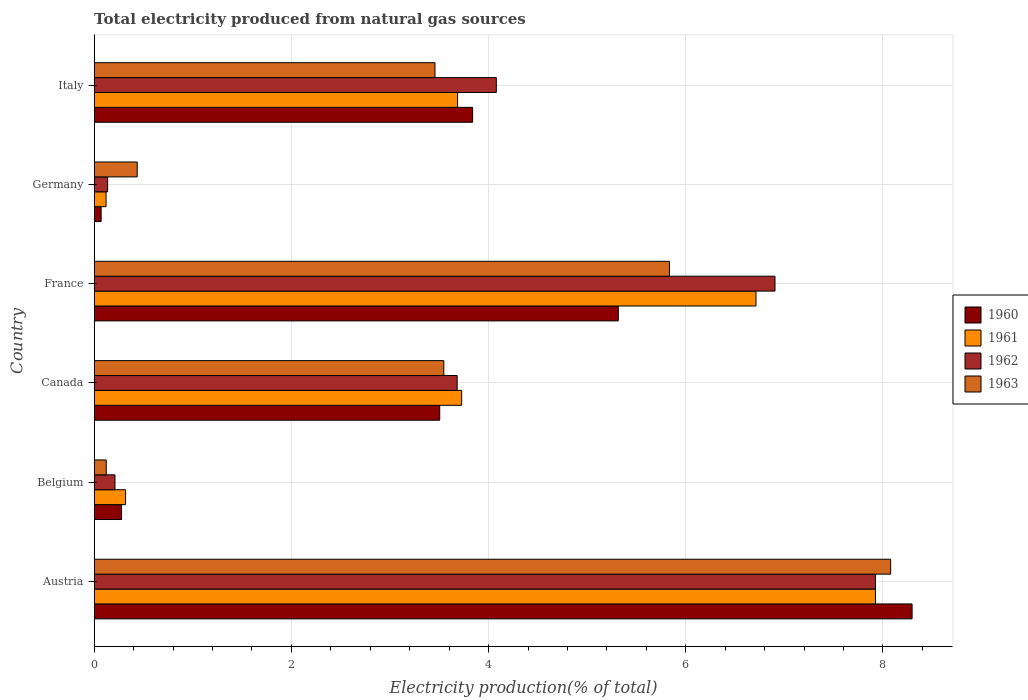Are the number of bars on each tick of the Y-axis equal?
Offer a very short reply. Yes. How many bars are there on the 6th tick from the bottom?
Keep it short and to the point. 4. In how many cases, is the number of bars for a given country not equal to the number of legend labels?
Give a very brief answer. 0. What is the total electricity produced in 1961 in Austria?
Provide a succinct answer. 7.92. Across all countries, what is the maximum total electricity produced in 1963?
Ensure brevity in your answer.  8.08. Across all countries, what is the minimum total electricity produced in 1961?
Provide a short and direct response. 0.12. What is the total total electricity produced in 1960 in the graph?
Give a very brief answer. 21.3. What is the difference between the total electricity produced in 1960 in Austria and that in Belgium?
Offer a very short reply. 8.02. What is the difference between the total electricity produced in 1961 in Austria and the total electricity produced in 1963 in Germany?
Your answer should be compact. 7.49. What is the average total electricity produced in 1961 per country?
Give a very brief answer. 3.75. What is the difference between the total electricity produced in 1963 and total electricity produced in 1961 in Austria?
Make the answer very short. 0.15. In how many countries, is the total electricity produced in 1960 greater than 5.2 %?
Your answer should be very brief. 2. What is the ratio of the total electricity produced in 1963 in Canada to that in Germany?
Keep it short and to the point. 8.13. What is the difference between the highest and the second highest total electricity produced in 1962?
Make the answer very short. 1.02. What is the difference between the highest and the lowest total electricity produced in 1962?
Provide a succinct answer. 7.79. In how many countries, is the total electricity produced in 1962 greater than the average total electricity produced in 1962 taken over all countries?
Provide a succinct answer. 3. Is the sum of the total electricity produced in 1960 in Belgium and Canada greater than the maximum total electricity produced in 1961 across all countries?
Provide a short and direct response. No. What does the 4th bar from the top in France represents?
Ensure brevity in your answer.  1960. What does the 4th bar from the bottom in Canada represents?
Give a very brief answer. 1963. How many bars are there?
Offer a very short reply. 24. Are all the bars in the graph horizontal?
Keep it short and to the point. Yes. How many countries are there in the graph?
Your answer should be compact. 6. What is the difference between two consecutive major ticks on the X-axis?
Your response must be concise. 2. Are the values on the major ticks of X-axis written in scientific E-notation?
Ensure brevity in your answer.  No. Does the graph contain any zero values?
Keep it short and to the point. No. Does the graph contain grids?
Offer a very short reply. Yes. Where does the legend appear in the graph?
Your answer should be very brief. Center right. How are the legend labels stacked?
Keep it short and to the point. Vertical. What is the title of the graph?
Your response must be concise. Total electricity produced from natural gas sources. Does "1966" appear as one of the legend labels in the graph?
Ensure brevity in your answer.  No. What is the label or title of the X-axis?
Give a very brief answer. Electricity production(% of total). What is the label or title of the Y-axis?
Provide a short and direct response. Country. What is the Electricity production(% of total) in 1960 in Austria?
Provide a succinct answer. 8.3. What is the Electricity production(% of total) of 1961 in Austria?
Your answer should be very brief. 7.92. What is the Electricity production(% of total) of 1962 in Austria?
Your response must be concise. 7.92. What is the Electricity production(% of total) of 1963 in Austria?
Keep it short and to the point. 8.08. What is the Electricity production(% of total) of 1960 in Belgium?
Keep it short and to the point. 0.28. What is the Electricity production(% of total) in 1961 in Belgium?
Offer a very short reply. 0.32. What is the Electricity production(% of total) of 1962 in Belgium?
Your answer should be very brief. 0.21. What is the Electricity production(% of total) of 1963 in Belgium?
Provide a short and direct response. 0.12. What is the Electricity production(% of total) in 1960 in Canada?
Provide a short and direct response. 3.5. What is the Electricity production(% of total) in 1961 in Canada?
Your answer should be very brief. 3.73. What is the Electricity production(% of total) of 1962 in Canada?
Your response must be concise. 3.68. What is the Electricity production(% of total) of 1963 in Canada?
Make the answer very short. 3.55. What is the Electricity production(% of total) in 1960 in France?
Make the answer very short. 5.32. What is the Electricity production(% of total) in 1961 in France?
Your answer should be very brief. 6.71. What is the Electricity production(% of total) in 1962 in France?
Offer a very short reply. 6.91. What is the Electricity production(% of total) of 1963 in France?
Provide a short and direct response. 5.83. What is the Electricity production(% of total) of 1960 in Germany?
Offer a terse response. 0.07. What is the Electricity production(% of total) of 1961 in Germany?
Make the answer very short. 0.12. What is the Electricity production(% of total) in 1962 in Germany?
Give a very brief answer. 0.14. What is the Electricity production(% of total) of 1963 in Germany?
Provide a short and direct response. 0.44. What is the Electricity production(% of total) of 1960 in Italy?
Keep it short and to the point. 3.84. What is the Electricity production(% of total) in 1961 in Italy?
Give a very brief answer. 3.69. What is the Electricity production(% of total) of 1962 in Italy?
Keep it short and to the point. 4.08. What is the Electricity production(% of total) in 1963 in Italy?
Provide a succinct answer. 3.46. Across all countries, what is the maximum Electricity production(% of total) in 1960?
Your answer should be very brief. 8.3. Across all countries, what is the maximum Electricity production(% of total) of 1961?
Keep it short and to the point. 7.92. Across all countries, what is the maximum Electricity production(% of total) of 1962?
Give a very brief answer. 7.92. Across all countries, what is the maximum Electricity production(% of total) of 1963?
Make the answer very short. 8.08. Across all countries, what is the minimum Electricity production(% of total) of 1960?
Your answer should be compact. 0.07. Across all countries, what is the minimum Electricity production(% of total) of 1961?
Your answer should be compact. 0.12. Across all countries, what is the minimum Electricity production(% of total) of 1962?
Keep it short and to the point. 0.14. Across all countries, what is the minimum Electricity production(% of total) in 1963?
Give a very brief answer. 0.12. What is the total Electricity production(% of total) of 1960 in the graph?
Give a very brief answer. 21.3. What is the total Electricity production(% of total) in 1961 in the graph?
Provide a short and direct response. 22.49. What is the total Electricity production(% of total) in 1962 in the graph?
Offer a terse response. 22.94. What is the total Electricity production(% of total) of 1963 in the graph?
Provide a succinct answer. 21.47. What is the difference between the Electricity production(% of total) in 1960 in Austria and that in Belgium?
Give a very brief answer. 8.02. What is the difference between the Electricity production(% of total) in 1961 in Austria and that in Belgium?
Give a very brief answer. 7.61. What is the difference between the Electricity production(% of total) of 1962 in Austria and that in Belgium?
Give a very brief answer. 7.71. What is the difference between the Electricity production(% of total) in 1963 in Austria and that in Belgium?
Provide a short and direct response. 7.96. What is the difference between the Electricity production(% of total) in 1960 in Austria and that in Canada?
Provide a short and direct response. 4.79. What is the difference between the Electricity production(% of total) in 1961 in Austria and that in Canada?
Provide a succinct answer. 4.2. What is the difference between the Electricity production(% of total) of 1962 in Austria and that in Canada?
Provide a succinct answer. 4.24. What is the difference between the Electricity production(% of total) of 1963 in Austria and that in Canada?
Your answer should be very brief. 4.53. What is the difference between the Electricity production(% of total) of 1960 in Austria and that in France?
Give a very brief answer. 2.98. What is the difference between the Electricity production(% of total) of 1961 in Austria and that in France?
Your response must be concise. 1.21. What is the difference between the Electricity production(% of total) of 1962 in Austria and that in France?
Give a very brief answer. 1.02. What is the difference between the Electricity production(% of total) of 1963 in Austria and that in France?
Ensure brevity in your answer.  2.24. What is the difference between the Electricity production(% of total) in 1960 in Austria and that in Germany?
Your answer should be compact. 8.23. What is the difference between the Electricity production(% of total) in 1961 in Austria and that in Germany?
Provide a succinct answer. 7.8. What is the difference between the Electricity production(% of total) of 1962 in Austria and that in Germany?
Keep it short and to the point. 7.79. What is the difference between the Electricity production(% of total) of 1963 in Austria and that in Germany?
Your response must be concise. 7.64. What is the difference between the Electricity production(% of total) of 1960 in Austria and that in Italy?
Provide a succinct answer. 4.46. What is the difference between the Electricity production(% of total) of 1961 in Austria and that in Italy?
Your answer should be compact. 4.24. What is the difference between the Electricity production(% of total) of 1962 in Austria and that in Italy?
Provide a short and direct response. 3.85. What is the difference between the Electricity production(% of total) in 1963 in Austria and that in Italy?
Make the answer very short. 4.62. What is the difference between the Electricity production(% of total) in 1960 in Belgium and that in Canada?
Give a very brief answer. -3.23. What is the difference between the Electricity production(% of total) in 1961 in Belgium and that in Canada?
Offer a terse response. -3.41. What is the difference between the Electricity production(% of total) of 1962 in Belgium and that in Canada?
Your answer should be very brief. -3.47. What is the difference between the Electricity production(% of total) of 1963 in Belgium and that in Canada?
Provide a succinct answer. -3.42. What is the difference between the Electricity production(% of total) of 1960 in Belgium and that in France?
Your response must be concise. -5.04. What is the difference between the Electricity production(% of total) in 1961 in Belgium and that in France?
Your response must be concise. -6.39. What is the difference between the Electricity production(% of total) in 1962 in Belgium and that in France?
Your answer should be compact. -6.69. What is the difference between the Electricity production(% of total) in 1963 in Belgium and that in France?
Make the answer very short. -5.71. What is the difference between the Electricity production(% of total) in 1960 in Belgium and that in Germany?
Ensure brevity in your answer.  0.21. What is the difference between the Electricity production(% of total) of 1961 in Belgium and that in Germany?
Your answer should be compact. 0.2. What is the difference between the Electricity production(% of total) in 1962 in Belgium and that in Germany?
Ensure brevity in your answer.  0.07. What is the difference between the Electricity production(% of total) of 1963 in Belgium and that in Germany?
Offer a terse response. -0.31. What is the difference between the Electricity production(% of total) of 1960 in Belgium and that in Italy?
Ensure brevity in your answer.  -3.56. What is the difference between the Electricity production(% of total) in 1961 in Belgium and that in Italy?
Offer a very short reply. -3.37. What is the difference between the Electricity production(% of total) of 1962 in Belgium and that in Italy?
Provide a short and direct response. -3.87. What is the difference between the Electricity production(% of total) of 1963 in Belgium and that in Italy?
Offer a terse response. -3.33. What is the difference between the Electricity production(% of total) in 1960 in Canada and that in France?
Give a very brief answer. -1.81. What is the difference between the Electricity production(% of total) in 1961 in Canada and that in France?
Offer a terse response. -2.99. What is the difference between the Electricity production(% of total) in 1962 in Canada and that in France?
Make the answer very short. -3.22. What is the difference between the Electricity production(% of total) in 1963 in Canada and that in France?
Your answer should be very brief. -2.29. What is the difference between the Electricity production(% of total) in 1960 in Canada and that in Germany?
Your answer should be very brief. 3.43. What is the difference between the Electricity production(% of total) in 1961 in Canada and that in Germany?
Your response must be concise. 3.61. What is the difference between the Electricity production(% of total) of 1962 in Canada and that in Germany?
Make the answer very short. 3.55. What is the difference between the Electricity production(% of total) in 1963 in Canada and that in Germany?
Ensure brevity in your answer.  3.11. What is the difference between the Electricity production(% of total) in 1960 in Canada and that in Italy?
Provide a short and direct response. -0.33. What is the difference between the Electricity production(% of total) in 1961 in Canada and that in Italy?
Provide a short and direct response. 0.04. What is the difference between the Electricity production(% of total) of 1962 in Canada and that in Italy?
Your response must be concise. -0.4. What is the difference between the Electricity production(% of total) in 1963 in Canada and that in Italy?
Make the answer very short. 0.09. What is the difference between the Electricity production(% of total) of 1960 in France and that in Germany?
Your answer should be very brief. 5.25. What is the difference between the Electricity production(% of total) in 1961 in France and that in Germany?
Your answer should be very brief. 6.59. What is the difference between the Electricity production(% of total) in 1962 in France and that in Germany?
Offer a very short reply. 6.77. What is the difference between the Electricity production(% of total) in 1963 in France and that in Germany?
Make the answer very short. 5.4. What is the difference between the Electricity production(% of total) in 1960 in France and that in Italy?
Offer a terse response. 1.48. What is the difference between the Electricity production(% of total) in 1961 in France and that in Italy?
Offer a very short reply. 3.03. What is the difference between the Electricity production(% of total) in 1962 in France and that in Italy?
Your answer should be very brief. 2.83. What is the difference between the Electricity production(% of total) of 1963 in France and that in Italy?
Your response must be concise. 2.38. What is the difference between the Electricity production(% of total) of 1960 in Germany and that in Italy?
Provide a succinct answer. -3.77. What is the difference between the Electricity production(% of total) in 1961 in Germany and that in Italy?
Give a very brief answer. -3.57. What is the difference between the Electricity production(% of total) in 1962 in Germany and that in Italy?
Offer a very short reply. -3.94. What is the difference between the Electricity production(% of total) in 1963 in Germany and that in Italy?
Offer a terse response. -3.02. What is the difference between the Electricity production(% of total) in 1960 in Austria and the Electricity production(% of total) in 1961 in Belgium?
Provide a short and direct response. 7.98. What is the difference between the Electricity production(% of total) in 1960 in Austria and the Electricity production(% of total) in 1962 in Belgium?
Your answer should be compact. 8.08. What is the difference between the Electricity production(% of total) in 1960 in Austria and the Electricity production(% of total) in 1963 in Belgium?
Provide a succinct answer. 8.17. What is the difference between the Electricity production(% of total) of 1961 in Austria and the Electricity production(% of total) of 1962 in Belgium?
Your answer should be very brief. 7.71. What is the difference between the Electricity production(% of total) of 1961 in Austria and the Electricity production(% of total) of 1963 in Belgium?
Offer a terse response. 7.8. What is the difference between the Electricity production(% of total) in 1962 in Austria and the Electricity production(% of total) in 1963 in Belgium?
Offer a very short reply. 7.8. What is the difference between the Electricity production(% of total) in 1960 in Austria and the Electricity production(% of total) in 1961 in Canada?
Ensure brevity in your answer.  4.57. What is the difference between the Electricity production(% of total) of 1960 in Austria and the Electricity production(% of total) of 1962 in Canada?
Your answer should be very brief. 4.61. What is the difference between the Electricity production(% of total) of 1960 in Austria and the Electricity production(% of total) of 1963 in Canada?
Your response must be concise. 4.75. What is the difference between the Electricity production(% of total) of 1961 in Austria and the Electricity production(% of total) of 1962 in Canada?
Your answer should be very brief. 4.24. What is the difference between the Electricity production(% of total) in 1961 in Austria and the Electricity production(% of total) in 1963 in Canada?
Give a very brief answer. 4.38. What is the difference between the Electricity production(% of total) in 1962 in Austria and the Electricity production(% of total) in 1963 in Canada?
Ensure brevity in your answer.  4.38. What is the difference between the Electricity production(% of total) in 1960 in Austria and the Electricity production(% of total) in 1961 in France?
Provide a succinct answer. 1.58. What is the difference between the Electricity production(% of total) of 1960 in Austria and the Electricity production(% of total) of 1962 in France?
Make the answer very short. 1.39. What is the difference between the Electricity production(% of total) in 1960 in Austria and the Electricity production(% of total) in 1963 in France?
Provide a succinct answer. 2.46. What is the difference between the Electricity production(% of total) in 1961 in Austria and the Electricity production(% of total) in 1963 in France?
Your answer should be compact. 2.09. What is the difference between the Electricity production(% of total) of 1962 in Austria and the Electricity production(% of total) of 1963 in France?
Ensure brevity in your answer.  2.09. What is the difference between the Electricity production(% of total) in 1960 in Austria and the Electricity production(% of total) in 1961 in Germany?
Provide a short and direct response. 8.18. What is the difference between the Electricity production(% of total) of 1960 in Austria and the Electricity production(% of total) of 1962 in Germany?
Offer a very short reply. 8.16. What is the difference between the Electricity production(% of total) in 1960 in Austria and the Electricity production(% of total) in 1963 in Germany?
Offer a very short reply. 7.86. What is the difference between the Electricity production(% of total) in 1961 in Austria and the Electricity production(% of total) in 1962 in Germany?
Give a very brief answer. 7.79. What is the difference between the Electricity production(% of total) in 1961 in Austria and the Electricity production(% of total) in 1963 in Germany?
Your response must be concise. 7.49. What is the difference between the Electricity production(% of total) of 1962 in Austria and the Electricity production(% of total) of 1963 in Germany?
Offer a terse response. 7.49. What is the difference between the Electricity production(% of total) in 1960 in Austria and the Electricity production(% of total) in 1961 in Italy?
Ensure brevity in your answer.  4.61. What is the difference between the Electricity production(% of total) of 1960 in Austria and the Electricity production(% of total) of 1962 in Italy?
Offer a very short reply. 4.22. What is the difference between the Electricity production(% of total) of 1960 in Austria and the Electricity production(% of total) of 1963 in Italy?
Your answer should be compact. 4.84. What is the difference between the Electricity production(% of total) of 1961 in Austria and the Electricity production(% of total) of 1962 in Italy?
Make the answer very short. 3.85. What is the difference between the Electricity production(% of total) in 1961 in Austria and the Electricity production(% of total) in 1963 in Italy?
Provide a short and direct response. 4.47. What is the difference between the Electricity production(% of total) of 1962 in Austria and the Electricity production(% of total) of 1963 in Italy?
Make the answer very short. 4.47. What is the difference between the Electricity production(% of total) of 1960 in Belgium and the Electricity production(% of total) of 1961 in Canada?
Provide a succinct answer. -3.45. What is the difference between the Electricity production(% of total) in 1960 in Belgium and the Electricity production(% of total) in 1962 in Canada?
Your response must be concise. -3.4. What is the difference between the Electricity production(% of total) of 1960 in Belgium and the Electricity production(% of total) of 1963 in Canada?
Provide a succinct answer. -3.27. What is the difference between the Electricity production(% of total) of 1961 in Belgium and the Electricity production(% of total) of 1962 in Canada?
Provide a short and direct response. -3.36. What is the difference between the Electricity production(% of total) of 1961 in Belgium and the Electricity production(% of total) of 1963 in Canada?
Give a very brief answer. -3.23. What is the difference between the Electricity production(% of total) in 1962 in Belgium and the Electricity production(% of total) in 1963 in Canada?
Keep it short and to the point. -3.34. What is the difference between the Electricity production(% of total) of 1960 in Belgium and the Electricity production(% of total) of 1961 in France?
Ensure brevity in your answer.  -6.43. What is the difference between the Electricity production(% of total) in 1960 in Belgium and the Electricity production(% of total) in 1962 in France?
Provide a succinct answer. -6.63. What is the difference between the Electricity production(% of total) in 1960 in Belgium and the Electricity production(% of total) in 1963 in France?
Offer a terse response. -5.56. What is the difference between the Electricity production(% of total) of 1961 in Belgium and the Electricity production(% of total) of 1962 in France?
Your answer should be compact. -6.59. What is the difference between the Electricity production(% of total) in 1961 in Belgium and the Electricity production(% of total) in 1963 in France?
Make the answer very short. -5.52. What is the difference between the Electricity production(% of total) in 1962 in Belgium and the Electricity production(% of total) in 1963 in France?
Provide a short and direct response. -5.62. What is the difference between the Electricity production(% of total) in 1960 in Belgium and the Electricity production(% of total) in 1961 in Germany?
Ensure brevity in your answer.  0.16. What is the difference between the Electricity production(% of total) of 1960 in Belgium and the Electricity production(% of total) of 1962 in Germany?
Ensure brevity in your answer.  0.14. What is the difference between the Electricity production(% of total) in 1960 in Belgium and the Electricity production(% of total) in 1963 in Germany?
Offer a very short reply. -0.16. What is the difference between the Electricity production(% of total) in 1961 in Belgium and the Electricity production(% of total) in 1962 in Germany?
Make the answer very short. 0.18. What is the difference between the Electricity production(% of total) of 1961 in Belgium and the Electricity production(% of total) of 1963 in Germany?
Your response must be concise. -0.12. What is the difference between the Electricity production(% of total) of 1962 in Belgium and the Electricity production(% of total) of 1963 in Germany?
Your answer should be very brief. -0.23. What is the difference between the Electricity production(% of total) in 1960 in Belgium and the Electricity production(% of total) in 1961 in Italy?
Keep it short and to the point. -3.41. What is the difference between the Electricity production(% of total) of 1960 in Belgium and the Electricity production(% of total) of 1962 in Italy?
Offer a terse response. -3.8. What is the difference between the Electricity production(% of total) in 1960 in Belgium and the Electricity production(% of total) in 1963 in Italy?
Provide a succinct answer. -3.18. What is the difference between the Electricity production(% of total) in 1961 in Belgium and the Electricity production(% of total) in 1962 in Italy?
Ensure brevity in your answer.  -3.76. What is the difference between the Electricity production(% of total) of 1961 in Belgium and the Electricity production(% of total) of 1963 in Italy?
Give a very brief answer. -3.14. What is the difference between the Electricity production(% of total) of 1962 in Belgium and the Electricity production(% of total) of 1963 in Italy?
Provide a short and direct response. -3.25. What is the difference between the Electricity production(% of total) of 1960 in Canada and the Electricity production(% of total) of 1961 in France?
Give a very brief answer. -3.21. What is the difference between the Electricity production(% of total) in 1960 in Canada and the Electricity production(% of total) in 1962 in France?
Give a very brief answer. -3.4. What is the difference between the Electricity production(% of total) in 1960 in Canada and the Electricity production(% of total) in 1963 in France?
Provide a short and direct response. -2.33. What is the difference between the Electricity production(% of total) of 1961 in Canada and the Electricity production(% of total) of 1962 in France?
Your answer should be compact. -3.18. What is the difference between the Electricity production(% of total) of 1961 in Canada and the Electricity production(% of total) of 1963 in France?
Your answer should be compact. -2.11. What is the difference between the Electricity production(% of total) in 1962 in Canada and the Electricity production(% of total) in 1963 in France?
Offer a terse response. -2.15. What is the difference between the Electricity production(% of total) of 1960 in Canada and the Electricity production(% of total) of 1961 in Germany?
Ensure brevity in your answer.  3.38. What is the difference between the Electricity production(% of total) in 1960 in Canada and the Electricity production(% of total) in 1962 in Germany?
Ensure brevity in your answer.  3.37. What is the difference between the Electricity production(% of total) of 1960 in Canada and the Electricity production(% of total) of 1963 in Germany?
Your answer should be very brief. 3.07. What is the difference between the Electricity production(% of total) in 1961 in Canada and the Electricity production(% of total) in 1962 in Germany?
Make the answer very short. 3.59. What is the difference between the Electricity production(% of total) of 1961 in Canada and the Electricity production(% of total) of 1963 in Germany?
Offer a terse response. 3.29. What is the difference between the Electricity production(% of total) in 1962 in Canada and the Electricity production(% of total) in 1963 in Germany?
Keep it short and to the point. 3.25. What is the difference between the Electricity production(% of total) in 1960 in Canada and the Electricity production(% of total) in 1961 in Italy?
Give a very brief answer. -0.18. What is the difference between the Electricity production(% of total) of 1960 in Canada and the Electricity production(% of total) of 1962 in Italy?
Give a very brief answer. -0.57. What is the difference between the Electricity production(% of total) in 1960 in Canada and the Electricity production(% of total) in 1963 in Italy?
Make the answer very short. 0.05. What is the difference between the Electricity production(% of total) in 1961 in Canada and the Electricity production(% of total) in 1962 in Italy?
Provide a succinct answer. -0.35. What is the difference between the Electricity production(% of total) of 1961 in Canada and the Electricity production(% of total) of 1963 in Italy?
Offer a very short reply. 0.27. What is the difference between the Electricity production(% of total) of 1962 in Canada and the Electricity production(% of total) of 1963 in Italy?
Keep it short and to the point. 0.23. What is the difference between the Electricity production(% of total) in 1960 in France and the Electricity production(% of total) in 1961 in Germany?
Give a very brief answer. 5.2. What is the difference between the Electricity production(% of total) in 1960 in France and the Electricity production(% of total) in 1962 in Germany?
Provide a succinct answer. 5.18. What is the difference between the Electricity production(% of total) of 1960 in France and the Electricity production(% of total) of 1963 in Germany?
Provide a short and direct response. 4.88. What is the difference between the Electricity production(% of total) in 1961 in France and the Electricity production(% of total) in 1962 in Germany?
Provide a succinct answer. 6.58. What is the difference between the Electricity production(% of total) of 1961 in France and the Electricity production(% of total) of 1963 in Germany?
Give a very brief answer. 6.28. What is the difference between the Electricity production(% of total) of 1962 in France and the Electricity production(% of total) of 1963 in Germany?
Give a very brief answer. 6.47. What is the difference between the Electricity production(% of total) of 1960 in France and the Electricity production(% of total) of 1961 in Italy?
Provide a succinct answer. 1.63. What is the difference between the Electricity production(% of total) in 1960 in France and the Electricity production(% of total) in 1962 in Italy?
Your answer should be very brief. 1.24. What is the difference between the Electricity production(% of total) of 1960 in France and the Electricity production(% of total) of 1963 in Italy?
Provide a short and direct response. 1.86. What is the difference between the Electricity production(% of total) of 1961 in France and the Electricity production(% of total) of 1962 in Italy?
Provide a short and direct response. 2.63. What is the difference between the Electricity production(% of total) of 1961 in France and the Electricity production(% of total) of 1963 in Italy?
Provide a short and direct response. 3.26. What is the difference between the Electricity production(% of total) of 1962 in France and the Electricity production(% of total) of 1963 in Italy?
Your response must be concise. 3.45. What is the difference between the Electricity production(% of total) in 1960 in Germany and the Electricity production(% of total) in 1961 in Italy?
Offer a terse response. -3.62. What is the difference between the Electricity production(% of total) in 1960 in Germany and the Electricity production(% of total) in 1962 in Italy?
Offer a terse response. -4.01. What is the difference between the Electricity production(% of total) in 1960 in Germany and the Electricity production(% of total) in 1963 in Italy?
Make the answer very short. -3.39. What is the difference between the Electricity production(% of total) in 1961 in Germany and the Electricity production(% of total) in 1962 in Italy?
Ensure brevity in your answer.  -3.96. What is the difference between the Electricity production(% of total) of 1961 in Germany and the Electricity production(% of total) of 1963 in Italy?
Your answer should be very brief. -3.34. What is the difference between the Electricity production(% of total) of 1962 in Germany and the Electricity production(% of total) of 1963 in Italy?
Ensure brevity in your answer.  -3.32. What is the average Electricity production(% of total) of 1960 per country?
Offer a very short reply. 3.55. What is the average Electricity production(% of total) in 1961 per country?
Your response must be concise. 3.75. What is the average Electricity production(% of total) of 1962 per country?
Your response must be concise. 3.82. What is the average Electricity production(% of total) in 1963 per country?
Make the answer very short. 3.58. What is the difference between the Electricity production(% of total) in 1960 and Electricity production(% of total) in 1961 in Austria?
Give a very brief answer. 0.37. What is the difference between the Electricity production(% of total) of 1960 and Electricity production(% of total) of 1962 in Austria?
Provide a short and direct response. 0.37. What is the difference between the Electricity production(% of total) of 1960 and Electricity production(% of total) of 1963 in Austria?
Offer a terse response. 0.22. What is the difference between the Electricity production(% of total) in 1961 and Electricity production(% of total) in 1963 in Austria?
Offer a terse response. -0.15. What is the difference between the Electricity production(% of total) in 1962 and Electricity production(% of total) in 1963 in Austria?
Your answer should be very brief. -0.15. What is the difference between the Electricity production(% of total) in 1960 and Electricity production(% of total) in 1961 in Belgium?
Make the answer very short. -0.04. What is the difference between the Electricity production(% of total) of 1960 and Electricity production(% of total) of 1962 in Belgium?
Your answer should be very brief. 0.07. What is the difference between the Electricity production(% of total) of 1960 and Electricity production(% of total) of 1963 in Belgium?
Keep it short and to the point. 0.15. What is the difference between the Electricity production(% of total) of 1961 and Electricity production(% of total) of 1962 in Belgium?
Provide a succinct answer. 0.11. What is the difference between the Electricity production(% of total) in 1961 and Electricity production(% of total) in 1963 in Belgium?
Make the answer very short. 0.2. What is the difference between the Electricity production(% of total) of 1962 and Electricity production(% of total) of 1963 in Belgium?
Your answer should be compact. 0.09. What is the difference between the Electricity production(% of total) of 1960 and Electricity production(% of total) of 1961 in Canada?
Keep it short and to the point. -0.22. What is the difference between the Electricity production(% of total) of 1960 and Electricity production(% of total) of 1962 in Canada?
Keep it short and to the point. -0.18. What is the difference between the Electricity production(% of total) of 1960 and Electricity production(% of total) of 1963 in Canada?
Make the answer very short. -0.04. What is the difference between the Electricity production(% of total) in 1961 and Electricity production(% of total) in 1962 in Canada?
Ensure brevity in your answer.  0.05. What is the difference between the Electricity production(% of total) of 1961 and Electricity production(% of total) of 1963 in Canada?
Give a very brief answer. 0.18. What is the difference between the Electricity production(% of total) in 1962 and Electricity production(% of total) in 1963 in Canada?
Keep it short and to the point. 0.14. What is the difference between the Electricity production(% of total) of 1960 and Electricity production(% of total) of 1961 in France?
Provide a succinct answer. -1.4. What is the difference between the Electricity production(% of total) of 1960 and Electricity production(% of total) of 1962 in France?
Make the answer very short. -1.59. What is the difference between the Electricity production(% of total) in 1960 and Electricity production(% of total) in 1963 in France?
Your response must be concise. -0.52. What is the difference between the Electricity production(% of total) in 1961 and Electricity production(% of total) in 1962 in France?
Make the answer very short. -0.19. What is the difference between the Electricity production(% of total) in 1961 and Electricity production(% of total) in 1963 in France?
Give a very brief answer. 0.88. What is the difference between the Electricity production(% of total) of 1962 and Electricity production(% of total) of 1963 in France?
Provide a succinct answer. 1.07. What is the difference between the Electricity production(% of total) in 1960 and Electricity production(% of total) in 1962 in Germany?
Your answer should be very brief. -0.07. What is the difference between the Electricity production(% of total) of 1960 and Electricity production(% of total) of 1963 in Germany?
Make the answer very short. -0.37. What is the difference between the Electricity production(% of total) of 1961 and Electricity production(% of total) of 1962 in Germany?
Make the answer very short. -0.02. What is the difference between the Electricity production(% of total) in 1961 and Electricity production(% of total) in 1963 in Germany?
Provide a succinct answer. -0.32. What is the difference between the Electricity production(% of total) of 1962 and Electricity production(% of total) of 1963 in Germany?
Provide a succinct answer. -0.3. What is the difference between the Electricity production(% of total) of 1960 and Electricity production(% of total) of 1961 in Italy?
Your response must be concise. 0.15. What is the difference between the Electricity production(% of total) in 1960 and Electricity production(% of total) in 1962 in Italy?
Offer a terse response. -0.24. What is the difference between the Electricity production(% of total) in 1960 and Electricity production(% of total) in 1963 in Italy?
Provide a short and direct response. 0.38. What is the difference between the Electricity production(% of total) of 1961 and Electricity production(% of total) of 1962 in Italy?
Offer a terse response. -0.39. What is the difference between the Electricity production(% of total) of 1961 and Electricity production(% of total) of 1963 in Italy?
Provide a short and direct response. 0.23. What is the difference between the Electricity production(% of total) of 1962 and Electricity production(% of total) of 1963 in Italy?
Your response must be concise. 0.62. What is the ratio of the Electricity production(% of total) of 1960 in Austria to that in Belgium?
Provide a short and direct response. 29.93. What is the ratio of the Electricity production(% of total) of 1961 in Austria to that in Belgium?
Offer a very short reply. 24.9. What is the ratio of the Electricity production(% of total) of 1962 in Austria to that in Belgium?
Keep it short and to the point. 37.57. What is the ratio of the Electricity production(% of total) of 1963 in Austria to that in Belgium?
Make the answer very short. 66.07. What is the ratio of the Electricity production(% of total) of 1960 in Austria to that in Canada?
Offer a very short reply. 2.37. What is the ratio of the Electricity production(% of total) in 1961 in Austria to that in Canada?
Provide a short and direct response. 2.13. What is the ratio of the Electricity production(% of total) in 1962 in Austria to that in Canada?
Ensure brevity in your answer.  2.15. What is the ratio of the Electricity production(% of total) of 1963 in Austria to that in Canada?
Your answer should be compact. 2.28. What is the ratio of the Electricity production(% of total) in 1960 in Austria to that in France?
Your answer should be compact. 1.56. What is the ratio of the Electricity production(% of total) in 1961 in Austria to that in France?
Your answer should be very brief. 1.18. What is the ratio of the Electricity production(% of total) in 1962 in Austria to that in France?
Ensure brevity in your answer.  1.15. What is the ratio of the Electricity production(% of total) in 1963 in Austria to that in France?
Your response must be concise. 1.38. What is the ratio of the Electricity production(% of total) in 1960 in Austria to that in Germany?
Offer a terse response. 118.01. What is the ratio of the Electricity production(% of total) of 1961 in Austria to that in Germany?
Make the answer very short. 65.86. What is the ratio of the Electricity production(% of total) in 1962 in Austria to that in Germany?
Offer a terse response. 58.17. What is the ratio of the Electricity production(% of total) in 1963 in Austria to that in Germany?
Provide a short and direct response. 18.52. What is the ratio of the Electricity production(% of total) of 1960 in Austria to that in Italy?
Ensure brevity in your answer.  2.16. What is the ratio of the Electricity production(% of total) in 1961 in Austria to that in Italy?
Offer a very short reply. 2.15. What is the ratio of the Electricity production(% of total) of 1962 in Austria to that in Italy?
Your answer should be compact. 1.94. What is the ratio of the Electricity production(% of total) of 1963 in Austria to that in Italy?
Offer a terse response. 2.34. What is the ratio of the Electricity production(% of total) in 1960 in Belgium to that in Canada?
Make the answer very short. 0.08. What is the ratio of the Electricity production(% of total) in 1961 in Belgium to that in Canada?
Keep it short and to the point. 0.09. What is the ratio of the Electricity production(% of total) in 1962 in Belgium to that in Canada?
Provide a succinct answer. 0.06. What is the ratio of the Electricity production(% of total) in 1963 in Belgium to that in Canada?
Make the answer very short. 0.03. What is the ratio of the Electricity production(% of total) in 1960 in Belgium to that in France?
Your response must be concise. 0.05. What is the ratio of the Electricity production(% of total) of 1961 in Belgium to that in France?
Your response must be concise. 0.05. What is the ratio of the Electricity production(% of total) in 1962 in Belgium to that in France?
Make the answer very short. 0.03. What is the ratio of the Electricity production(% of total) in 1963 in Belgium to that in France?
Your response must be concise. 0.02. What is the ratio of the Electricity production(% of total) of 1960 in Belgium to that in Germany?
Ensure brevity in your answer.  3.94. What is the ratio of the Electricity production(% of total) of 1961 in Belgium to that in Germany?
Give a very brief answer. 2.64. What is the ratio of the Electricity production(% of total) of 1962 in Belgium to that in Germany?
Keep it short and to the point. 1.55. What is the ratio of the Electricity production(% of total) of 1963 in Belgium to that in Germany?
Your answer should be very brief. 0.28. What is the ratio of the Electricity production(% of total) of 1960 in Belgium to that in Italy?
Provide a succinct answer. 0.07. What is the ratio of the Electricity production(% of total) of 1961 in Belgium to that in Italy?
Your answer should be very brief. 0.09. What is the ratio of the Electricity production(% of total) of 1962 in Belgium to that in Italy?
Provide a short and direct response. 0.05. What is the ratio of the Electricity production(% of total) in 1963 in Belgium to that in Italy?
Provide a succinct answer. 0.04. What is the ratio of the Electricity production(% of total) of 1960 in Canada to that in France?
Your response must be concise. 0.66. What is the ratio of the Electricity production(% of total) of 1961 in Canada to that in France?
Offer a terse response. 0.56. What is the ratio of the Electricity production(% of total) in 1962 in Canada to that in France?
Keep it short and to the point. 0.53. What is the ratio of the Electricity production(% of total) of 1963 in Canada to that in France?
Offer a terse response. 0.61. What is the ratio of the Electricity production(% of total) in 1960 in Canada to that in Germany?
Make the answer very short. 49.85. What is the ratio of the Electricity production(% of total) of 1961 in Canada to that in Germany?
Your response must be concise. 30.98. What is the ratio of the Electricity production(% of total) in 1962 in Canada to that in Germany?
Offer a very short reply. 27.02. What is the ratio of the Electricity production(% of total) of 1963 in Canada to that in Germany?
Give a very brief answer. 8.13. What is the ratio of the Electricity production(% of total) in 1960 in Canada to that in Italy?
Your answer should be very brief. 0.91. What is the ratio of the Electricity production(% of total) in 1961 in Canada to that in Italy?
Offer a very short reply. 1.01. What is the ratio of the Electricity production(% of total) in 1962 in Canada to that in Italy?
Offer a very short reply. 0.9. What is the ratio of the Electricity production(% of total) in 1963 in Canada to that in Italy?
Keep it short and to the point. 1.03. What is the ratio of the Electricity production(% of total) in 1960 in France to that in Germany?
Make the answer very short. 75.62. What is the ratio of the Electricity production(% of total) in 1961 in France to that in Germany?
Your answer should be very brief. 55.79. What is the ratio of the Electricity production(% of total) of 1962 in France to that in Germany?
Make the answer very short. 50.69. What is the ratio of the Electricity production(% of total) of 1963 in France to that in Germany?
Keep it short and to the point. 13.38. What is the ratio of the Electricity production(% of total) in 1960 in France to that in Italy?
Your response must be concise. 1.39. What is the ratio of the Electricity production(% of total) in 1961 in France to that in Italy?
Your answer should be very brief. 1.82. What is the ratio of the Electricity production(% of total) of 1962 in France to that in Italy?
Ensure brevity in your answer.  1.69. What is the ratio of the Electricity production(% of total) of 1963 in France to that in Italy?
Ensure brevity in your answer.  1.69. What is the ratio of the Electricity production(% of total) in 1960 in Germany to that in Italy?
Offer a very short reply. 0.02. What is the ratio of the Electricity production(% of total) of 1961 in Germany to that in Italy?
Your answer should be compact. 0.03. What is the ratio of the Electricity production(% of total) of 1962 in Germany to that in Italy?
Offer a very short reply. 0.03. What is the ratio of the Electricity production(% of total) of 1963 in Germany to that in Italy?
Your answer should be very brief. 0.13. What is the difference between the highest and the second highest Electricity production(% of total) in 1960?
Your answer should be very brief. 2.98. What is the difference between the highest and the second highest Electricity production(% of total) in 1961?
Your answer should be very brief. 1.21. What is the difference between the highest and the second highest Electricity production(% of total) in 1962?
Your response must be concise. 1.02. What is the difference between the highest and the second highest Electricity production(% of total) in 1963?
Provide a succinct answer. 2.24. What is the difference between the highest and the lowest Electricity production(% of total) in 1960?
Your answer should be very brief. 8.23. What is the difference between the highest and the lowest Electricity production(% of total) of 1961?
Your response must be concise. 7.8. What is the difference between the highest and the lowest Electricity production(% of total) in 1962?
Provide a succinct answer. 7.79. What is the difference between the highest and the lowest Electricity production(% of total) in 1963?
Offer a terse response. 7.96. 